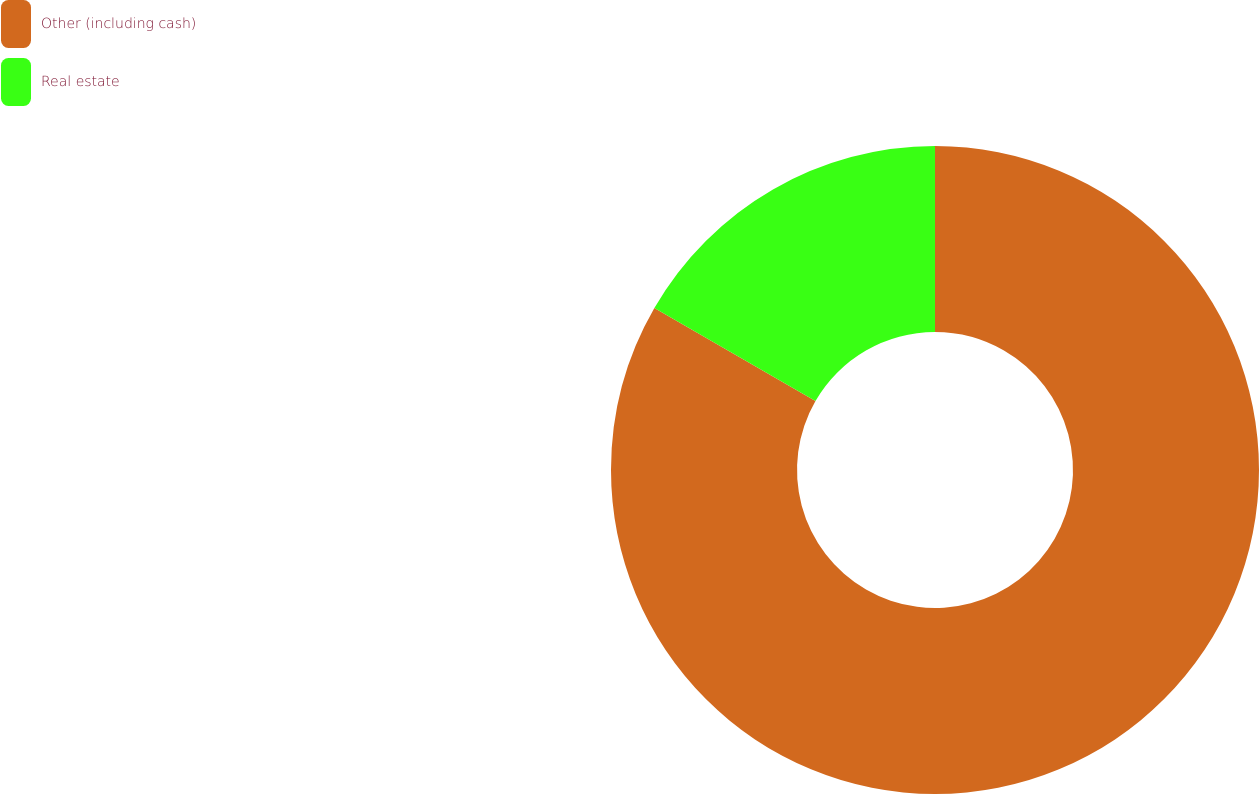Convert chart to OTSL. <chart><loc_0><loc_0><loc_500><loc_500><pie_chart><fcel>Other (including cash)<fcel>Real estate<nl><fcel>83.33%<fcel>16.67%<nl></chart> 